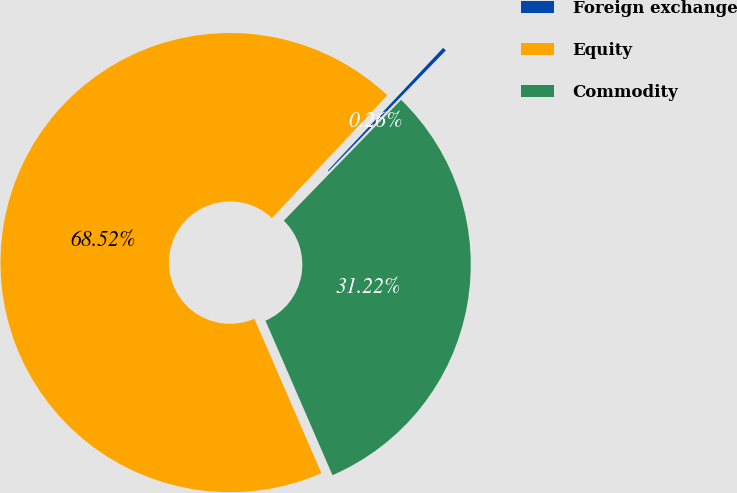<chart> <loc_0><loc_0><loc_500><loc_500><pie_chart><fcel>Foreign exchange<fcel>Equity<fcel>Commodity<nl><fcel>0.26%<fcel>68.51%<fcel>31.22%<nl></chart> 